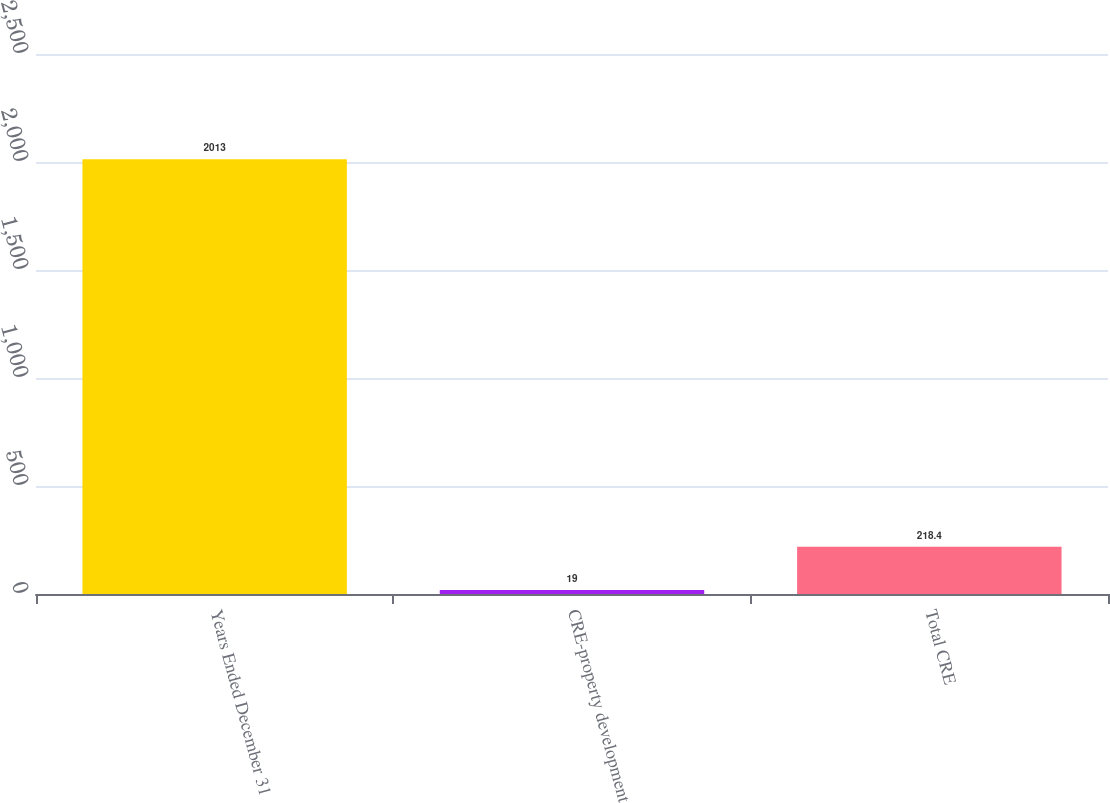Convert chart. <chart><loc_0><loc_0><loc_500><loc_500><bar_chart><fcel>Years Ended December 31<fcel>CRE-property development<fcel>Total CRE<nl><fcel>2013<fcel>19<fcel>218.4<nl></chart> 